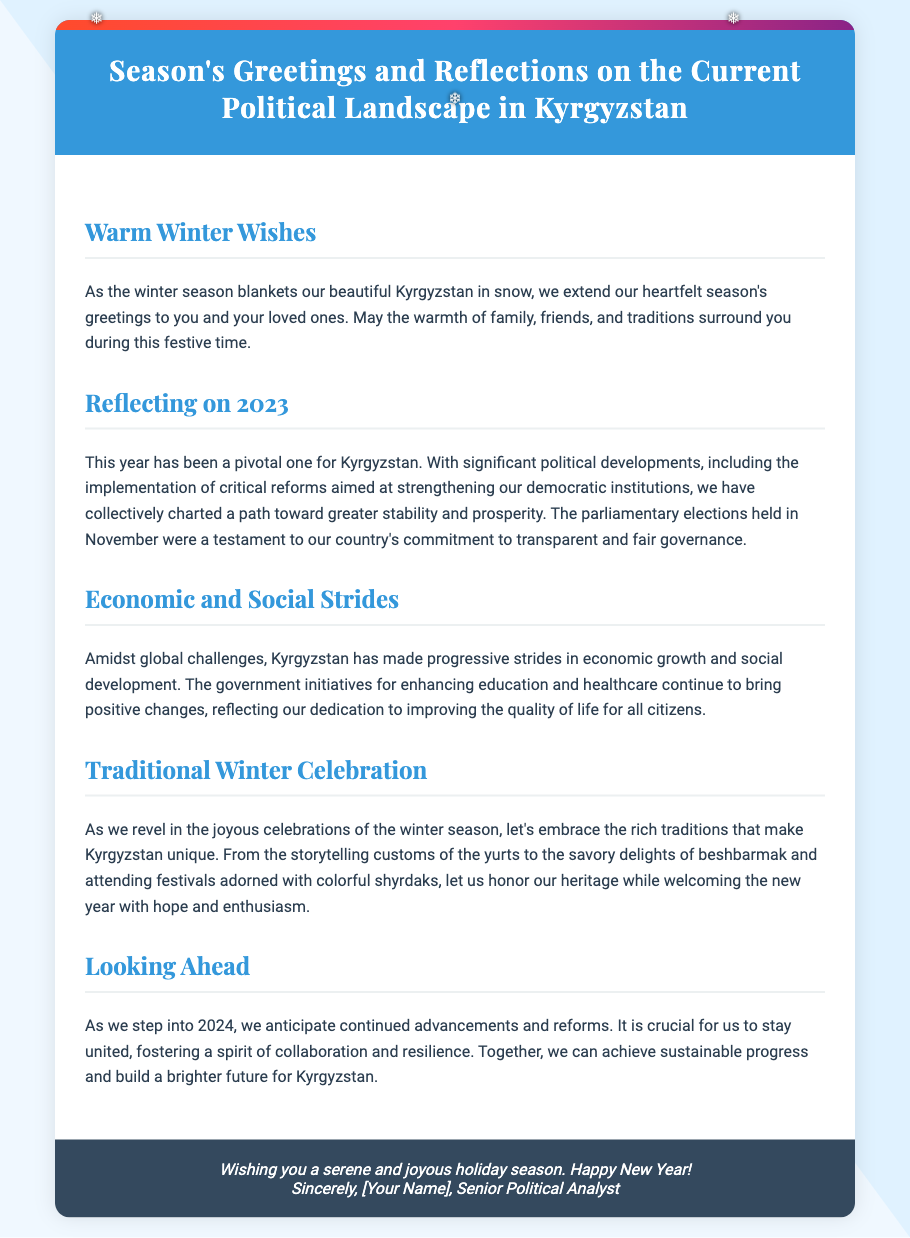What is the title of the card? The title of the card is stated in the header as "Season's Greetings and Reflections on the Current Political Landscape in Kyrgyzstan."
Answer: Season's Greetings and Reflections on the Current Political Landscape in Kyrgyzstan What year were the parliamentary elections held? The document explicitly mentions that parliamentary elections were held in November 2023.
Answer: November 2023 What is the name of the traditional dish mentioned in the card? The card references "beshbarmak" as a savory delight associated with Kyrgyzstan's traditions.
Answer: beshbarmak What does the author wish for the holiday season? The footer of the card conveys well wishes, including a "serene and joyous holiday season."
Answer: serene and joyous holiday season What is the anticipated focus for Kyrgyzstan in 2024? The text highlights the expectation of "continued advancements and reforms" for Kyrgyzstan in the upcoming year.
Answer: continued advancements and reforms How does the card describe the current political developments? The document states that the current political developments are characterized by "critical reforms aimed at strengthening our democratic institutions."
Answer: critical reforms aimed at strengthening our democratic institutions What cultural custom is mentioned in relation to winter celebrations? The card includes storytelling customs as part of the rich traditions celebrated during winter.
Answer: storytelling customs What seasonal backdrop does the card set for its message? The card sets a backdrop of winter, describing it as a season that "blankets our beautiful Kyrgyzstan in snow."
Answer: blankets our beautiful Kyrgyzstan in snow 